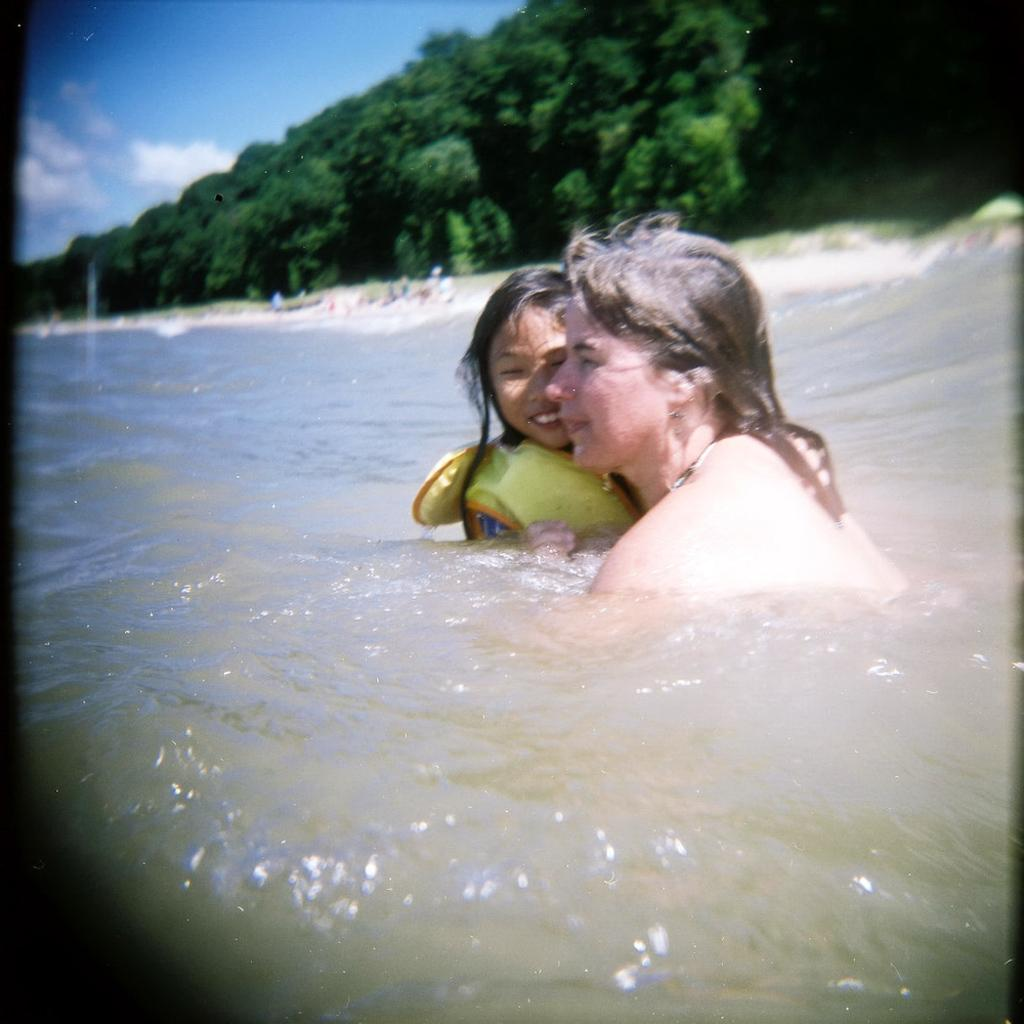What type of location is depicted in the image? There is a beach in the image. What are the two persons in the image doing? They are in the water. What type of terrain is present at the beach? There is sand in the image. What else can be seen in the background of the image? There are trees and the sky visible in the image. What type of stitch is being used to sew the pie in the image? There is no pie or stitching present in the image; it features a beach with two persons in the water. What color is the spark emitted by the trees in the image? There is no spark emitted by the trees in the image; it simply shows trees in the background. 